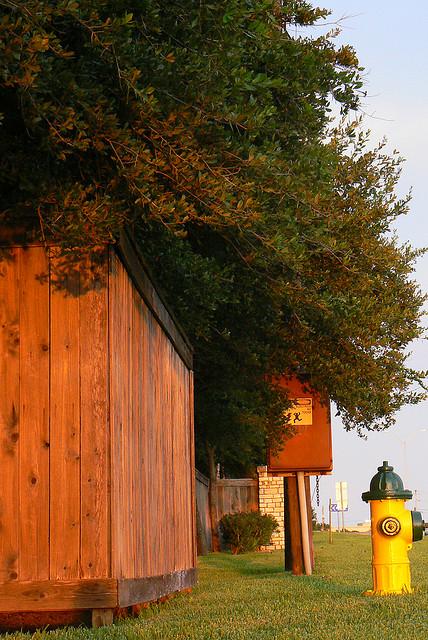What colors are the fire hydrant?
Be succinct. Yellow and green. What is the weather?
Be succinct. Sunny. Where is the fire hydrant?
Concise answer only. On grass. 